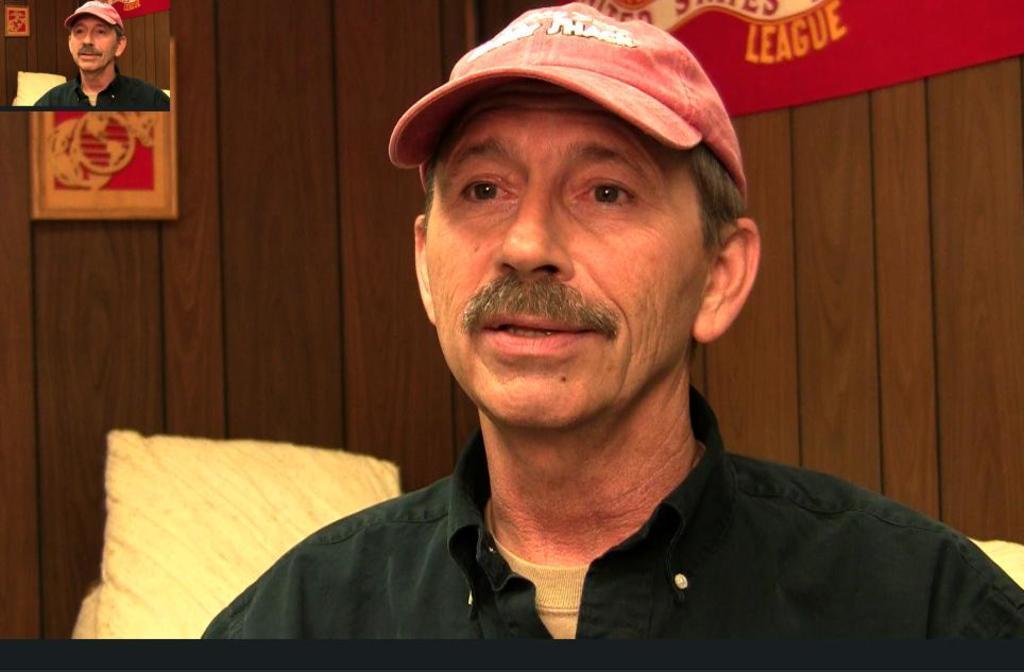Describe this image in one or two sentences. In the foreground of the picture there is a man wearing a cap and a dark green shirt. Behind him there is a couch. In the background there is a wooden wall and a poster. On the left there is a frame and a picture of a person. 